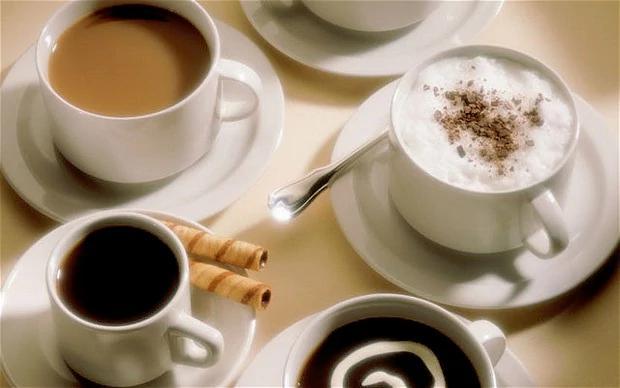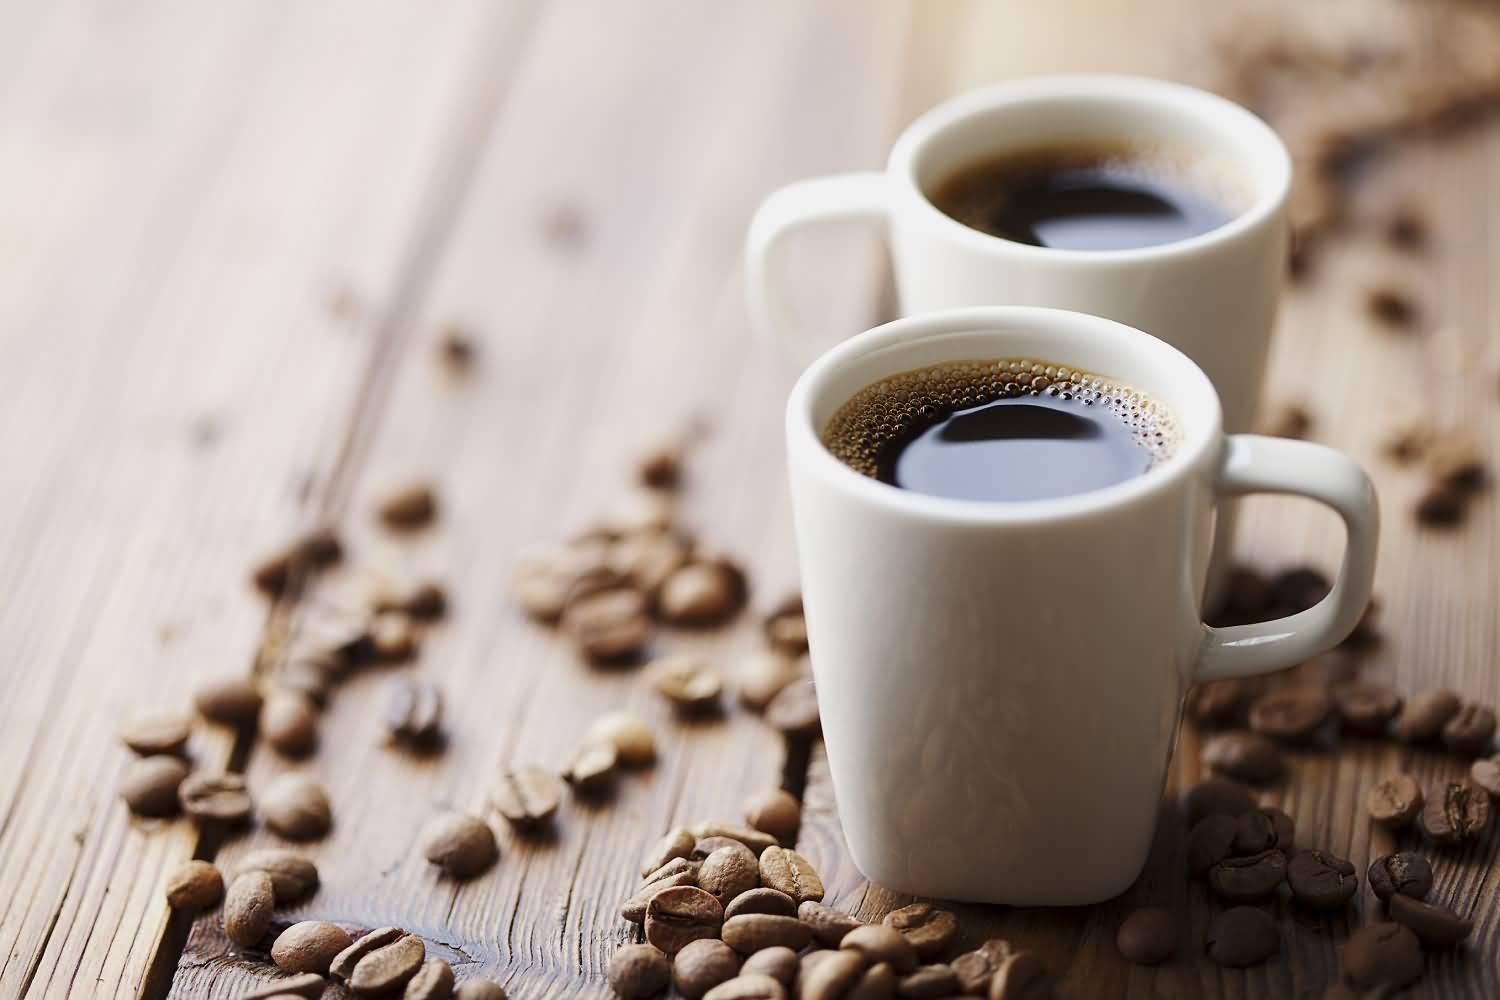The first image is the image on the left, the second image is the image on the right. For the images shown, is this caption "Each image shows two hot drinks served in matching cups with handles, seen at angle where the contents are visible." true? Answer yes or no. No. The first image is the image on the left, the second image is the image on the right. For the images shown, is this caption "An image shows exactly two side-by-side cups of beverages on saucers, without spoons." true? Answer yes or no. No. The first image is the image on the left, the second image is the image on the right. Examine the images to the left and right. Is the description "The two white cups in the image on the left are sitting in saucers." accurate? Answer yes or no. No. 